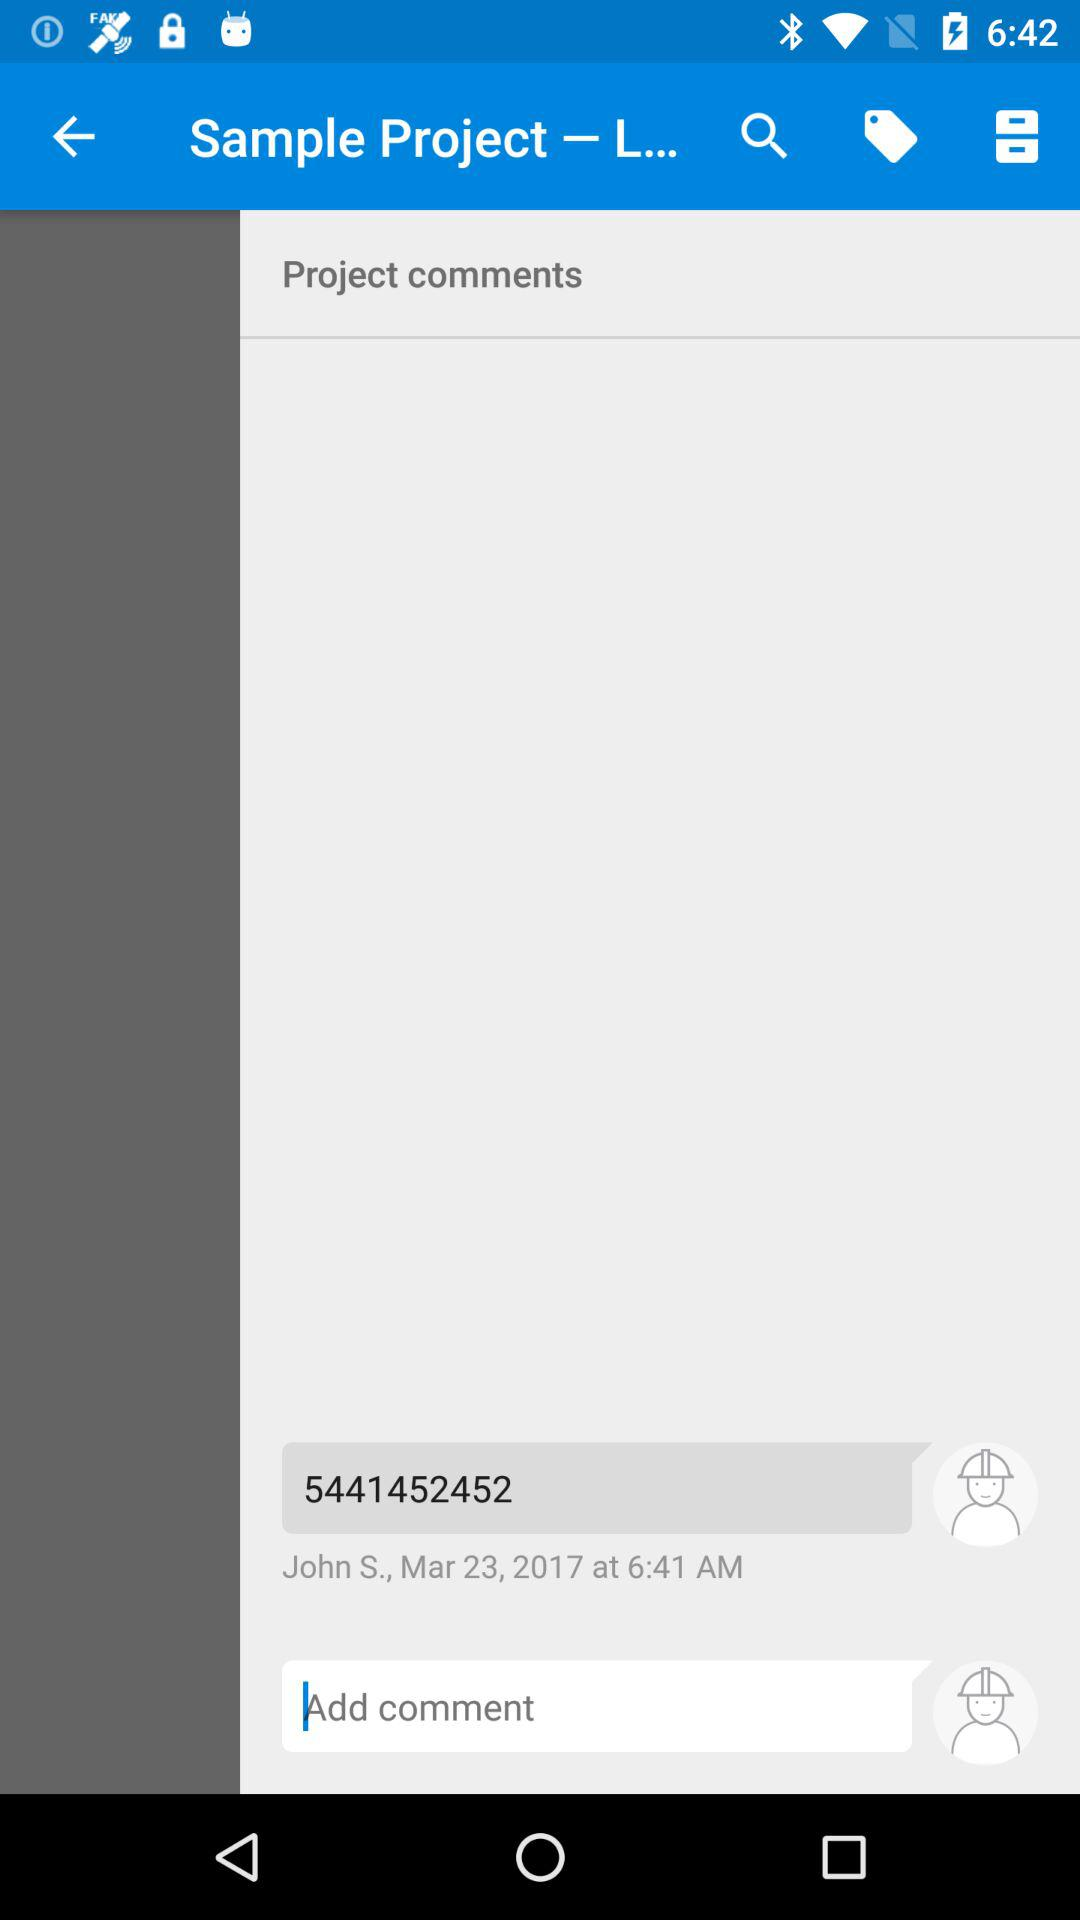At what time did John S. comment? John S. commented at 6:41 a.m. 